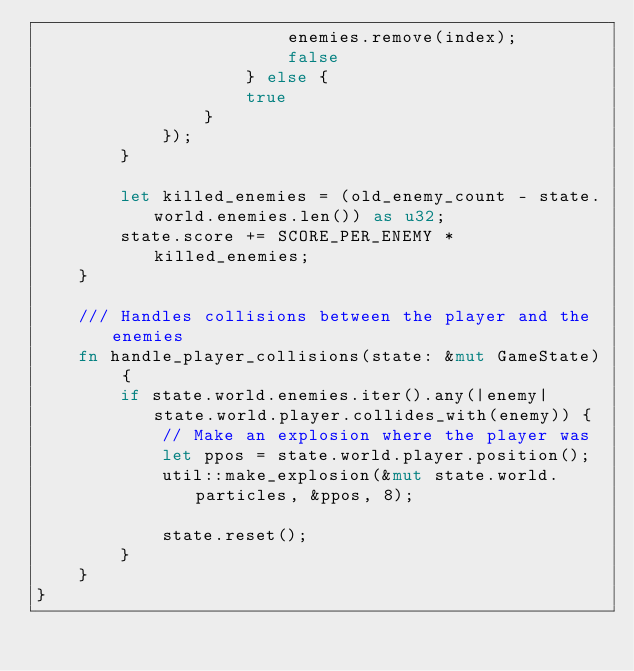<code> <loc_0><loc_0><loc_500><loc_500><_Rust_>                        enemies.remove(index);
                        false
                    } else {
                    true
                }
            });
        }

        let killed_enemies = (old_enemy_count - state.world.enemies.len()) as u32;
        state.score += SCORE_PER_ENEMY * killed_enemies;
    }

    /// Handles collisions between the player and the enemies
    fn handle_player_collisions(state: &mut GameState) {
        if state.world.enemies.iter().any(|enemy| state.world.player.collides_with(enemy)) {
            // Make an explosion where the player was
            let ppos = state.world.player.position();
            util::make_explosion(&mut state.world.particles, &ppos, 8);

            state.reset();
        }
    }
}
</code> 